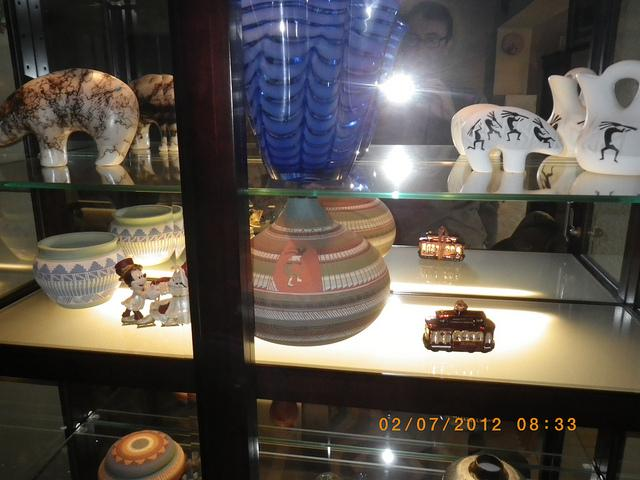What is the mouse's wife's name? Please explain your reasoning. minnie. Minnie is mickey's wife. 